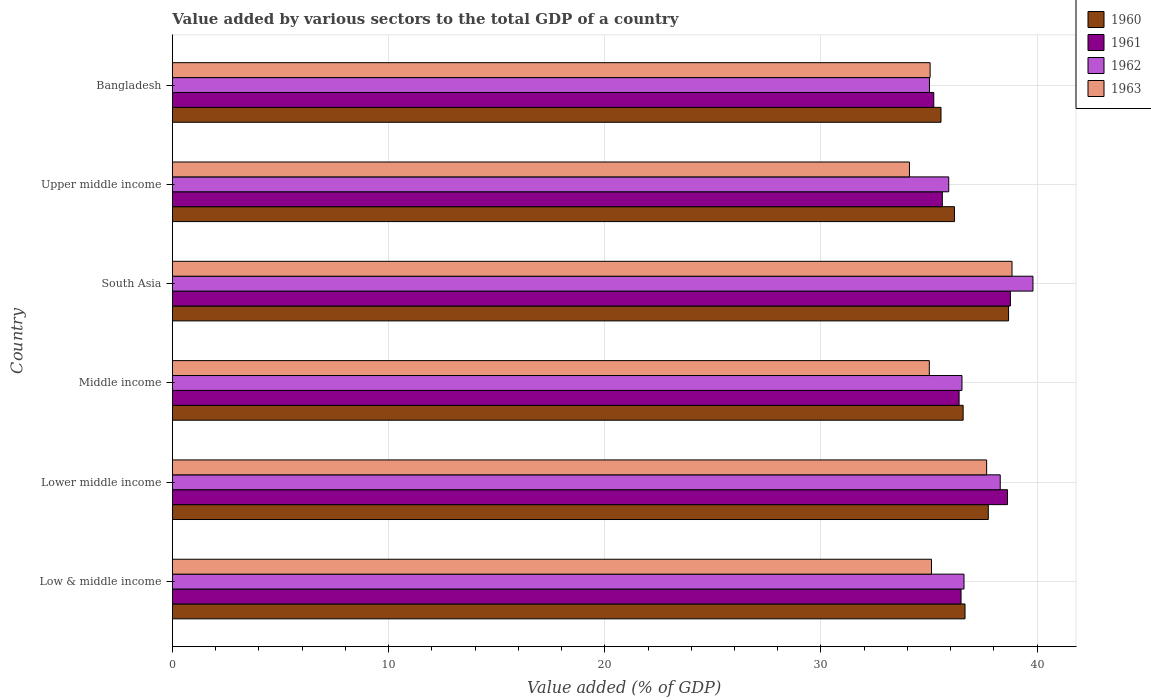How many bars are there on the 3rd tick from the top?
Offer a very short reply. 4. In how many cases, is the number of bars for a given country not equal to the number of legend labels?
Provide a short and direct response. 0. What is the value added by various sectors to the total GDP in 1962 in Upper middle income?
Ensure brevity in your answer.  35.91. Across all countries, what is the maximum value added by various sectors to the total GDP in 1960?
Keep it short and to the point. 38.68. Across all countries, what is the minimum value added by various sectors to the total GDP in 1962?
Your answer should be compact. 35.02. In which country was the value added by various sectors to the total GDP in 1960 maximum?
Offer a terse response. South Asia. What is the total value added by various sectors to the total GDP in 1962 in the graph?
Give a very brief answer. 222.16. What is the difference between the value added by various sectors to the total GDP in 1960 in Lower middle income and that in Middle income?
Provide a short and direct response. 1.16. What is the difference between the value added by various sectors to the total GDP in 1963 in Middle income and the value added by various sectors to the total GDP in 1961 in Low & middle income?
Offer a terse response. -1.47. What is the average value added by various sectors to the total GDP in 1960 per country?
Your answer should be very brief. 36.9. What is the difference between the value added by various sectors to the total GDP in 1963 and value added by various sectors to the total GDP in 1962 in South Asia?
Offer a very short reply. -0.97. What is the ratio of the value added by various sectors to the total GDP in 1962 in Middle income to that in South Asia?
Provide a succinct answer. 0.92. What is the difference between the highest and the second highest value added by various sectors to the total GDP in 1962?
Make the answer very short. 1.51. What is the difference between the highest and the lowest value added by various sectors to the total GDP in 1962?
Make the answer very short. 4.79. In how many countries, is the value added by various sectors to the total GDP in 1963 greater than the average value added by various sectors to the total GDP in 1963 taken over all countries?
Offer a very short reply. 2. Is the sum of the value added by various sectors to the total GDP in 1960 in South Asia and Upper middle income greater than the maximum value added by various sectors to the total GDP in 1961 across all countries?
Your answer should be compact. Yes. Is it the case that in every country, the sum of the value added by various sectors to the total GDP in 1960 and value added by various sectors to the total GDP in 1961 is greater than the sum of value added by various sectors to the total GDP in 1963 and value added by various sectors to the total GDP in 1962?
Your response must be concise. No. What does the 4th bar from the top in Middle income represents?
Provide a short and direct response. 1960. Is it the case that in every country, the sum of the value added by various sectors to the total GDP in 1963 and value added by various sectors to the total GDP in 1962 is greater than the value added by various sectors to the total GDP in 1961?
Give a very brief answer. Yes. Are all the bars in the graph horizontal?
Offer a terse response. Yes. Are the values on the major ticks of X-axis written in scientific E-notation?
Your answer should be very brief. No. Does the graph contain any zero values?
Offer a terse response. No. What is the title of the graph?
Your answer should be very brief. Value added by various sectors to the total GDP of a country. What is the label or title of the X-axis?
Your answer should be compact. Value added (% of GDP). What is the Value added (% of GDP) in 1960 in Low & middle income?
Provide a short and direct response. 36.66. What is the Value added (% of GDP) of 1961 in Low & middle income?
Make the answer very short. 36.48. What is the Value added (% of GDP) in 1962 in Low & middle income?
Give a very brief answer. 36.62. What is the Value added (% of GDP) of 1963 in Low & middle income?
Ensure brevity in your answer.  35.11. What is the Value added (% of GDP) of 1960 in Lower middle income?
Provide a succinct answer. 37.74. What is the Value added (% of GDP) in 1961 in Lower middle income?
Provide a succinct answer. 38.63. What is the Value added (% of GDP) in 1962 in Lower middle income?
Keep it short and to the point. 38.29. What is the Value added (% of GDP) in 1963 in Lower middle income?
Keep it short and to the point. 37.66. What is the Value added (% of GDP) of 1960 in Middle income?
Keep it short and to the point. 36.58. What is the Value added (% of GDP) in 1961 in Middle income?
Ensure brevity in your answer.  36.39. What is the Value added (% of GDP) in 1962 in Middle income?
Make the answer very short. 36.52. What is the Value added (% of GDP) of 1963 in Middle income?
Provide a succinct answer. 35.01. What is the Value added (% of GDP) of 1960 in South Asia?
Keep it short and to the point. 38.68. What is the Value added (% of GDP) of 1961 in South Asia?
Keep it short and to the point. 38.76. What is the Value added (% of GDP) in 1962 in South Asia?
Give a very brief answer. 39.81. What is the Value added (% of GDP) of 1963 in South Asia?
Your answer should be very brief. 38.84. What is the Value added (% of GDP) of 1960 in Upper middle income?
Make the answer very short. 36.17. What is the Value added (% of GDP) of 1961 in Upper middle income?
Offer a terse response. 35.61. What is the Value added (% of GDP) of 1962 in Upper middle income?
Give a very brief answer. 35.91. What is the Value added (% of GDP) of 1963 in Upper middle income?
Give a very brief answer. 34.09. What is the Value added (% of GDP) in 1960 in Bangladesh?
Offer a very short reply. 35.55. What is the Value added (% of GDP) of 1961 in Bangladesh?
Keep it short and to the point. 35.22. What is the Value added (% of GDP) of 1962 in Bangladesh?
Offer a very short reply. 35.02. What is the Value added (% of GDP) of 1963 in Bangladesh?
Provide a succinct answer. 35.05. Across all countries, what is the maximum Value added (% of GDP) of 1960?
Give a very brief answer. 38.68. Across all countries, what is the maximum Value added (% of GDP) of 1961?
Your answer should be compact. 38.76. Across all countries, what is the maximum Value added (% of GDP) of 1962?
Your answer should be very brief. 39.81. Across all countries, what is the maximum Value added (% of GDP) of 1963?
Your answer should be compact. 38.84. Across all countries, what is the minimum Value added (% of GDP) in 1960?
Your response must be concise. 35.55. Across all countries, what is the minimum Value added (% of GDP) of 1961?
Offer a terse response. 35.22. Across all countries, what is the minimum Value added (% of GDP) in 1962?
Your answer should be very brief. 35.02. Across all countries, what is the minimum Value added (% of GDP) of 1963?
Provide a succinct answer. 34.09. What is the total Value added (% of GDP) of 1960 in the graph?
Your answer should be compact. 221.38. What is the total Value added (% of GDP) of 1961 in the graph?
Your answer should be compact. 221.09. What is the total Value added (% of GDP) in 1962 in the graph?
Give a very brief answer. 222.16. What is the total Value added (% of GDP) in 1963 in the graph?
Ensure brevity in your answer.  215.76. What is the difference between the Value added (% of GDP) of 1960 in Low & middle income and that in Lower middle income?
Make the answer very short. -1.08. What is the difference between the Value added (% of GDP) of 1961 in Low & middle income and that in Lower middle income?
Give a very brief answer. -2.15. What is the difference between the Value added (% of GDP) of 1962 in Low & middle income and that in Lower middle income?
Your response must be concise. -1.68. What is the difference between the Value added (% of GDP) in 1963 in Low & middle income and that in Lower middle income?
Offer a very short reply. -2.55. What is the difference between the Value added (% of GDP) of 1960 in Low & middle income and that in Middle income?
Offer a very short reply. 0.09. What is the difference between the Value added (% of GDP) in 1961 in Low & middle income and that in Middle income?
Your answer should be very brief. 0.09. What is the difference between the Value added (% of GDP) of 1962 in Low & middle income and that in Middle income?
Offer a terse response. 0.09. What is the difference between the Value added (% of GDP) in 1963 in Low & middle income and that in Middle income?
Ensure brevity in your answer.  0.1. What is the difference between the Value added (% of GDP) in 1960 in Low & middle income and that in South Asia?
Provide a succinct answer. -2.01. What is the difference between the Value added (% of GDP) in 1961 in Low & middle income and that in South Asia?
Offer a terse response. -2.28. What is the difference between the Value added (% of GDP) of 1962 in Low & middle income and that in South Asia?
Keep it short and to the point. -3.19. What is the difference between the Value added (% of GDP) in 1963 in Low & middle income and that in South Asia?
Your answer should be very brief. -3.72. What is the difference between the Value added (% of GDP) in 1960 in Low & middle income and that in Upper middle income?
Your answer should be very brief. 0.49. What is the difference between the Value added (% of GDP) of 1961 in Low & middle income and that in Upper middle income?
Give a very brief answer. 0.87. What is the difference between the Value added (% of GDP) of 1962 in Low & middle income and that in Upper middle income?
Give a very brief answer. 0.71. What is the difference between the Value added (% of GDP) of 1963 in Low & middle income and that in Upper middle income?
Give a very brief answer. 1.02. What is the difference between the Value added (% of GDP) in 1960 in Low & middle income and that in Bangladesh?
Provide a short and direct response. 1.11. What is the difference between the Value added (% of GDP) of 1961 in Low & middle income and that in Bangladesh?
Offer a very short reply. 1.26. What is the difference between the Value added (% of GDP) in 1962 in Low & middle income and that in Bangladesh?
Your response must be concise. 1.6. What is the difference between the Value added (% of GDP) of 1963 in Low & middle income and that in Bangladesh?
Offer a very short reply. 0.06. What is the difference between the Value added (% of GDP) of 1960 in Lower middle income and that in Middle income?
Provide a succinct answer. 1.16. What is the difference between the Value added (% of GDP) of 1961 in Lower middle income and that in Middle income?
Offer a very short reply. 2.24. What is the difference between the Value added (% of GDP) in 1962 in Lower middle income and that in Middle income?
Your answer should be compact. 1.77. What is the difference between the Value added (% of GDP) of 1963 in Lower middle income and that in Middle income?
Keep it short and to the point. 2.65. What is the difference between the Value added (% of GDP) of 1960 in Lower middle income and that in South Asia?
Provide a short and direct response. -0.94. What is the difference between the Value added (% of GDP) of 1961 in Lower middle income and that in South Asia?
Provide a succinct answer. -0.13. What is the difference between the Value added (% of GDP) in 1962 in Lower middle income and that in South Asia?
Your answer should be very brief. -1.51. What is the difference between the Value added (% of GDP) in 1963 in Lower middle income and that in South Asia?
Make the answer very short. -1.17. What is the difference between the Value added (% of GDP) of 1960 in Lower middle income and that in Upper middle income?
Your answer should be compact. 1.57. What is the difference between the Value added (% of GDP) of 1961 in Lower middle income and that in Upper middle income?
Your answer should be very brief. 3.02. What is the difference between the Value added (% of GDP) in 1962 in Lower middle income and that in Upper middle income?
Keep it short and to the point. 2.38. What is the difference between the Value added (% of GDP) of 1963 in Lower middle income and that in Upper middle income?
Your response must be concise. 3.57. What is the difference between the Value added (% of GDP) in 1960 in Lower middle income and that in Bangladesh?
Your response must be concise. 2.19. What is the difference between the Value added (% of GDP) of 1961 in Lower middle income and that in Bangladesh?
Provide a succinct answer. 3.41. What is the difference between the Value added (% of GDP) of 1962 in Lower middle income and that in Bangladesh?
Ensure brevity in your answer.  3.27. What is the difference between the Value added (% of GDP) in 1963 in Lower middle income and that in Bangladesh?
Your answer should be compact. 2.61. What is the difference between the Value added (% of GDP) of 1960 in Middle income and that in South Asia?
Your answer should be compact. -2.1. What is the difference between the Value added (% of GDP) in 1961 in Middle income and that in South Asia?
Your answer should be very brief. -2.37. What is the difference between the Value added (% of GDP) in 1962 in Middle income and that in South Asia?
Your answer should be compact. -3.28. What is the difference between the Value added (% of GDP) of 1963 in Middle income and that in South Asia?
Provide a short and direct response. -3.83. What is the difference between the Value added (% of GDP) of 1960 in Middle income and that in Upper middle income?
Your answer should be very brief. 0.4. What is the difference between the Value added (% of GDP) in 1961 in Middle income and that in Upper middle income?
Provide a succinct answer. 0.78. What is the difference between the Value added (% of GDP) of 1962 in Middle income and that in Upper middle income?
Give a very brief answer. 0.61. What is the difference between the Value added (% of GDP) in 1963 in Middle income and that in Upper middle income?
Your answer should be compact. 0.92. What is the difference between the Value added (% of GDP) of 1960 in Middle income and that in Bangladesh?
Your response must be concise. 1.02. What is the difference between the Value added (% of GDP) in 1961 in Middle income and that in Bangladesh?
Your response must be concise. 1.17. What is the difference between the Value added (% of GDP) of 1962 in Middle income and that in Bangladesh?
Your answer should be compact. 1.5. What is the difference between the Value added (% of GDP) of 1963 in Middle income and that in Bangladesh?
Provide a short and direct response. -0.04. What is the difference between the Value added (% of GDP) of 1960 in South Asia and that in Upper middle income?
Make the answer very short. 2.5. What is the difference between the Value added (% of GDP) of 1961 in South Asia and that in Upper middle income?
Offer a terse response. 3.15. What is the difference between the Value added (% of GDP) of 1962 in South Asia and that in Upper middle income?
Offer a terse response. 3.9. What is the difference between the Value added (% of GDP) of 1963 in South Asia and that in Upper middle income?
Make the answer very short. 4.74. What is the difference between the Value added (% of GDP) in 1960 in South Asia and that in Bangladesh?
Your answer should be very brief. 3.12. What is the difference between the Value added (% of GDP) of 1961 in South Asia and that in Bangladesh?
Your answer should be very brief. 3.54. What is the difference between the Value added (% of GDP) in 1962 in South Asia and that in Bangladesh?
Ensure brevity in your answer.  4.79. What is the difference between the Value added (% of GDP) of 1963 in South Asia and that in Bangladesh?
Provide a short and direct response. 3.79. What is the difference between the Value added (% of GDP) in 1960 in Upper middle income and that in Bangladesh?
Your response must be concise. 0.62. What is the difference between the Value added (% of GDP) of 1961 in Upper middle income and that in Bangladesh?
Your answer should be compact. 0.4. What is the difference between the Value added (% of GDP) in 1962 in Upper middle income and that in Bangladesh?
Give a very brief answer. 0.89. What is the difference between the Value added (% of GDP) of 1963 in Upper middle income and that in Bangladesh?
Give a very brief answer. -0.96. What is the difference between the Value added (% of GDP) in 1960 in Low & middle income and the Value added (% of GDP) in 1961 in Lower middle income?
Offer a terse response. -1.97. What is the difference between the Value added (% of GDP) in 1960 in Low & middle income and the Value added (% of GDP) in 1962 in Lower middle income?
Ensure brevity in your answer.  -1.63. What is the difference between the Value added (% of GDP) in 1960 in Low & middle income and the Value added (% of GDP) in 1963 in Lower middle income?
Provide a short and direct response. -1. What is the difference between the Value added (% of GDP) of 1961 in Low & middle income and the Value added (% of GDP) of 1962 in Lower middle income?
Provide a short and direct response. -1.81. What is the difference between the Value added (% of GDP) in 1961 in Low & middle income and the Value added (% of GDP) in 1963 in Lower middle income?
Provide a short and direct response. -1.18. What is the difference between the Value added (% of GDP) of 1962 in Low & middle income and the Value added (% of GDP) of 1963 in Lower middle income?
Give a very brief answer. -1.05. What is the difference between the Value added (% of GDP) in 1960 in Low & middle income and the Value added (% of GDP) in 1961 in Middle income?
Your answer should be compact. 0.27. What is the difference between the Value added (% of GDP) in 1960 in Low & middle income and the Value added (% of GDP) in 1962 in Middle income?
Offer a terse response. 0.14. What is the difference between the Value added (% of GDP) of 1960 in Low & middle income and the Value added (% of GDP) of 1963 in Middle income?
Your answer should be very brief. 1.65. What is the difference between the Value added (% of GDP) in 1961 in Low & middle income and the Value added (% of GDP) in 1962 in Middle income?
Your answer should be compact. -0.04. What is the difference between the Value added (% of GDP) of 1961 in Low & middle income and the Value added (% of GDP) of 1963 in Middle income?
Keep it short and to the point. 1.47. What is the difference between the Value added (% of GDP) in 1962 in Low & middle income and the Value added (% of GDP) in 1963 in Middle income?
Your response must be concise. 1.6. What is the difference between the Value added (% of GDP) of 1960 in Low & middle income and the Value added (% of GDP) of 1961 in South Asia?
Give a very brief answer. -2.1. What is the difference between the Value added (% of GDP) of 1960 in Low & middle income and the Value added (% of GDP) of 1962 in South Asia?
Give a very brief answer. -3.14. What is the difference between the Value added (% of GDP) in 1960 in Low & middle income and the Value added (% of GDP) in 1963 in South Asia?
Offer a terse response. -2.17. What is the difference between the Value added (% of GDP) of 1961 in Low & middle income and the Value added (% of GDP) of 1962 in South Asia?
Make the answer very short. -3.33. What is the difference between the Value added (% of GDP) of 1961 in Low & middle income and the Value added (% of GDP) of 1963 in South Asia?
Provide a succinct answer. -2.36. What is the difference between the Value added (% of GDP) of 1962 in Low & middle income and the Value added (% of GDP) of 1963 in South Asia?
Keep it short and to the point. -2.22. What is the difference between the Value added (% of GDP) in 1960 in Low & middle income and the Value added (% of GDP) in 1961 in Upper middle income?
Your response must be concise. 1.05. What is the difference between the Value added (% of GDP) in 1960 in Low & middle income and the Value added (% of GDP) in 1962 in Upper middle income?
Make the answer very short. 0.75. What is the difference between the Value added (% of GDP) in 1960 in Low & middle income and the Value added (% of GDP) in 1963 in Upper middle income?
Your response must be concise. 2.57. What is the difference between the Value added (% of GDP) in 1961 in Low & middle income and the Value added (% of GDP) in 1962 in Upper middle income?
Give a very brief answer. 0.57. What is the difference between the Value added (% of GDP) of 1961 in Low & middle income and the Value added (% of GDP) of 1963 in Upper middle income?
Provide a short and direct response. 2.39. What is the difference between the Value added (% of GDP) of 1962 in Low & middle income and the Value added (% of GDP) of 1963 in Upper middle income?
Your answer should be compact. 2.52. What is the difference between the Value added (% of GDP) in 1960 in Low & middle income and the Value added (% of GDP) in 1961 in Bangladesh?
Offer a terse response. 1.44. What is the difference between the Value added (% of GDP) of 1960 in Low & middle income and the Value added (% of GDP) of 1962 in Bangladesh?
Offer a terse response. 1.65. What is the difference between the Value added (% of GDP) in 1960 in Low & middle income and the Value added (% of GDP) in 1963 in Bangladesh?
Provide a short and direct response. 1.61. What is the difference between the Value added (% of GDP) of 1961 in Low & middle income and the Value added (% of GDP) of 1962 in Bangladesh?
Provide a succinct answer. 1.46. What is the difference between the Value added (% of GDP) of 1961 in Low & middle income and the Value added (% of GDP) of 1963 in Bangladesh?
Keep it short and to the point. 1.43. What is the difference between the Value added (% of GDP) of 1962 in Low & middle income and the Value added (% of GDP) of 1963 in Bangladesh?
Your response must be concise. 1.57. What is the difference between the Value added (% of GDP) in 1960 in Lower middle income and the Value added (% of GDP) in 1961 in Middle income?
Your answer should be compact. 1.35. What is the difference between the Value added (% of GDP) in 1960 in Lower middle income and the Value added (% of GDP) in 1962 in Middle income?
Offer a terse response. 1.22. What is the difference between the Value added (% of GDP) in 1960 in Lower middle income and the Value added (% of GDP) in 1963 in Middle income?
Keep it short and to the point. 2.73. What is the difference between the Value added (% of GDP) in 1961 in Lower middle income and the Value added (% of GDP) in 1962 in Middle income?
Make the answer very short. 2.11. What is the difference between the Value added (% of GDP) in 1961 in Lower middle income and the Value added (% of GDP) in 1963 in Middle income?
Your answer should be compact. 3.62. What is the difference between the Value added (% of GDP) of 1962 in Lower middle income and the Value added (% of GDP) of 1963 in Middle income?
Give a very brief answer. 3.28. What is the difference between the Value added (% of GDP) in 1960 in Lower middle income and the Value added (% of GDP) in 1961 in South Asia?
Offer a very short reply. -1.02. What is the difference between the Value added (% of GDP) in 1960 in Lower middle income and the Value added (% of GDP) in 1962 in South Asia?
Ensure brevity in your answer.  -2.07. What is the difference between the Value added (% of GDP) of 1960 in Lower middle income and the Value added (% of GDP) of 1963 in South Asia?
Make the answer very short. -1.1. What is the difference between the Value added (% of GDP) in 1961 in Lower middle income and the Value added (% of GDP) in 1962 in South Asia?
Make the answer very short. -1.18. What is the difference between the Value added (% of GDP) of 1961 in Lower middle income and the Value added (% of GDP) of 1963 in South Asia?
Your answer should be very brief. -0.21. What is the difference between the Value added (% of GDP) in 1962 in Lower middle income and the Value added (% of GDP) in 1963 in South Asia?
Provide a succinct answer. -0.55. What is the difference between the Value added (% of GDP) in 1960 in Lower middle income and the Value added (% of GDP) in 1961 in Upper middle income?
Ensure brevity in your answer.  2.13. What is the difference between the Value added (% of GDP) of 1960 in Lower middle income and the Value added (% of GDP) of 1962 in Upper middle income?
Your answer should be compact. 1.83. What is the difference between the Value added (% of GDP) of 1960 in Lower middle income and the Value added (% of GDP) of 1963 in Upper middle income?
Ensure brevity in your answer.  3.65. What is the difference between the Value added (% of GDP) of 1961 in Lower middle income and the Value added (% of GDP) of 1962 in Upper middle income?
Make the answer very short. 2.72. What is the difference between the Value added (% of GDP) in 1961 in Lower middle income and the Value added (% of GDP) in 1963 in Upper middle income?
Give a very brief answer. 4.54. What is the difference between the Value added (% of GDP) in 1962 in Lower middle income and the Value added (% of GDP) in 1963 in Upper middle income?
Provide a short and direct response. 4.2. What is the difference between the Value added (% of GDP) in 1960 in Lower middle income and the Value added (% of GDP) in 1961 in Bangladesh?
Keep it short and to the point. 2.52. What is the difference between the Value added (% of GDP) in 1960 in Lower middle income and the Value added (% of GDP) in 1962 in Bangladesh?
Your response must be concise. 2.72. What is the difference between the Value added (% of GDP) in 1960 in Lower middle income and the Value added (% of GDP) in 1963 in Bangladesh?
Your answer should be compact. 2.69. What is the difference between the Value added (% of GDP) of 1961 in Lower middle income and the Value added (% of GDP) of 1962 in Bangladesh?
Make the answer very short. 3.61. What is the difference between the Value added (% of GDP) in 1961 in Lower middle income and the Value added (% of GDP) in 1963 in Bangladesh?
Give a very brief answer. 3.58. What is the difference between the Value added (% of GDP) in 1962 in Lower middle income and the Value added (% of GDP) in 1963 in Bangladesh?
Ensure brevity in your answer.  3.24. What is the difference between the Value added (% of GDP) of 1960 in Middle income and the Value added (% of GDP) of 1961 in South Asia?
Your answer should be compact. -2.19. What is the difference between the Value added (% of GDP) in 1960 in Middle income and the Value added (% of GDP) in 1962 in South Asia?
Your answer should be very brief. -3.23. What is the difference between the Value added (% of GDP) in 1960 in Middle income and the Value added (% of GDP) in 1963 in South Asia?
Offer a very short reply. -2.26. What is the difference between the Value added (% of GDP) in 1961 in Middle income and the Value added (% of GDP) in 1962 in South Asia?
Give a very brief answer. -3.42. What is the difference between the Value added (% of GDP) of 1961 in Middle income and the Value added (% of GDP) of 1963 in South Asia?
Ensure brevity in your answer.  -2.45. What is the difference between the Value added (% of GDP) in 1962 in Middle income and the Value added (% of GDP) in 1963 in South Asia?
Provide a succinct answer. -2.31. What is the difference between the Value added (% of GDP) in 1960 in Middle income and the Value added (% of GDP) in 1961 in Upper middle income?
Provide a succinct answer. 0.96. What is the difference between the Value added (% of GDP) in 1960 in Middle income and the Value added (% of GDP) in 1962 in Upper middle income?
Ensure brevity in your answer.  0.67. What is the difference between the Value added (% of GDP) of 1960 in Middle income and the Value added (% of GDP) of 1963 in Upper middle income?
Your answer should be compact. 2.48. What is the difference between the Value added (% of GDP) in 1961 in Middle income and the Value added (% of GDP) in 1962 in Upper middle income?
Ensure brevity in your answer.  0.48. What is the difference between the Value added (% of GDP) of 1961 in Middle income and the Value added (% of GDP) of 1963 in Upper middle income?
Your response must be concise. 2.3. What is the difference between the Value added (% of GDP) of 1962 in Middle income and the Value added (% of GDP) of 1963 in Upper middle income?
Keep it short and to the point. 2.43. What is the difference between the Value added (% of GDP) of 1960 in Middle income and the Value added (% of GDP) of 1961 in Bangladesh?
Give a very brief answer. 1.36. What is the difference between the Value added (% of GDP) of 1960 in Middle income and the Value added (% of GDP) of 1962 in Bangladesh?
Offer a terse response. 1.56. What is the difference between the Value added (% of GDP) in 1960 in Middle income and the Value added (% of GDP) in 1963 in Bangladesh?
Offer a very short reply. 1.53. What is the difference between the Value added (% of GDP) in 1961 in Middle income and the Value added (% of GDP) in 1962 in Bangladesh?
Keep it short and to the point. 1.37. What is the difference between the Value added (% of GDP) of 1961 in Middle income and the Value added (% of GDP) of 1963 in Bangladesh?
Provide a short and direct response. 1.34. What is the difference between the Value added (% of GDP) in 1962 in Middle income and the Value added (% of GDP) in 1963 in Bangladesh?
Ensure brevity in your answer.  1.47. What is the difference between the Value added (% of GDP) in 1960 in South Asia and the Value added (% of GDP) in 1961 in Upper middle income?
Your answer should be compact. 3.06. What is the difference between the Value added (% of GDP) in 1960 in South Asia and the Value added (% of GDP) in 1962 in Upper middle income?
Offer a terse response. 2.77. What is the difference between the Value added (% of GDP) in 1960 in South Asia and the Value added (% of GDP) in 1963 in Upper middle income?
Offer a terse response. 4.58. What is the difference between the Value added (% of GDP) in 1961 in South Asia and the Value added (% of GDP) in 1962 in Upper middle income?
Your answer should be compact. 2.85. What is the difference between the Value added (% of GDP) of 1961 in South Asia and the Value added (% of GDP) of 1963 in Upper middle income?
Offer a very short reply. 4.67. What is the difference between the Value added (% of GDP) of 1962 in South Asia and the Value added (% of GDP) of 1963 in Upper middle income?
Keep it short and to the point. 5.71. What is the difference between the Value added (% of GDP) of 1960 in South Asia and the Value added (% of GDP) of 1961 in Bangladesh?
Ensure brevity in your answer.  3.46. What is the difference between the Value added (% of GDP) in 1960 in South Asia and the Value added (% of GDP) in 1962 in Bangladesh?
Your answer should be compact. 3.66. What is the difference between the Value added (% of GDP) in 1960 in South Asia and the Value added (% of GDP) in 1963 in Bangladesh?
Make the answer very short. 3.63. What is the difference between the Value added (% of GDP) of 1961 in South Asia and the Value added (% of GDP) of 1962 in Bangladesh?
Your answer should be very brief. 3.74. What is the difference between the Value added (% of GDP) of 1961 in South Asia and the Value added (% of GDP) of 1963 in Bangladesh?
Provide a short and direct response. 3.71. What is the difference between the Value added (% of GDP) in 1962 in South Asia and the Value added (% of GDP) in 1963 in Bangladesh?
Provide a short and direct response. 4.76. What is the difference between the Value added (% of GDP) in 1960 in Upper middle income and the Value added (% of GDP) in 1961 in Bangladesh?
Your answer should be compact. 0.96. What is the difference between the Value added (% of GDP) of 1960 in Upper middle income and the Value added (% of GDP) of 1962 in Bangladesh?
Offer a terse response. 1.16. What is the difference between the Value added (% of GDP) in 1960 in Upper middle income and the Value added (% of GDP) in 1963 in Bangladesh?
Ensure brevity in your answer.  1.12. What is the difference between the Value added (% of GDP) in 1961 in Upper middle income and the Value added (% of GDP) in 1962 in Bangladesh?
Give a very brief answer. 0.6. What is the difference between the Value added (% of GDP) of 1961 in Upper middle income and the Value added (% of GDP) of 1963 in Bangladesh?
Provide a succinct answer. 0.56. What is the difference between the Value added (% of GDP) of 1962 in Upper middle income and the Value added (% of GDP) of 1963 in Bangladesh?
Offer a terse response. 0.86. What is the average Value added (% of GDP) in 1960 per country?
Make the answer very short. 36.9. What is the average Value added (% of GDP) of 1961 per country?
Offer a terse response. 36.85. What is the average Value added (% of GDP) in 1962 per country?
Your answer should be very brief. 37.03. What is the average Value added (% of GDP) of 1963 per country?
Provide a short and direct response. 35.96. What is the difference between the Value added (% of GDP) of 1960 and Value added (% of GDP) of 1961 in Low & middle income?
Ensure brevity in your answer.  0.18. What is the difference between the Value added (% of GDP) in 1960 and Value added (% of GDP) in 1962 in Low & middle income?
Offer a terse response. 0.05. What is the difference between the Value added (% of GDP) of 1960 and Value added (% of GDP) of 1963 in Low & middle income?
Give a very brief answer. 1.55. What is the difference between the Value added (% of GDP) of 1961 and Value added (% of GDP) of 1962 in Low & middle income?
Your answer should be very brief. -0.14. What is the difference between the Value added (% of GDP) in 1961 and Value added (% of GDP) in 1963 in Low & middle income?
Offer a terse response. 1.37. What is the difference between the Value added (% of GDP) in 1962 and Value added (% of GDP) in 1963 in Low & middle income?
Provide a short and direct response. 1.5. What is the difference between the Value added (% of GDP) of 1960 and Value added (% of GDP) of 1961 in Lower middle income?
Your answer should be very brief. -0.89. What is the difference between the Value added (% of GDP) in 1960 and Value added (% of GDP) in 1962 in Lower middle income?
Offer a terse response. -0.55. What is the difference between the Value added (% of GDP) in 1960 and Value added (% of GDP) in 1963 in Lower middle income?
Offer a terse response. 0.08. What is the difference between the Value added (% of GDP) in 1961 and Value added (% of GDP) in 1962 in Lower middle income?
Offer a terse response. 0.34. What is the difference between the Value added (% of GDP) in 1961 and Value added (% of GDP) in 1963 in Lower middle income?
Provide a short and direct response. 0.97. What is the difference between the Value added (% of GDP) in 1962 and Value added (% of GDP) in 1963 in Lower middle income?
Make the answer very short. 0.63. What is the difference between the Value added (% of GDP) in 1960 and Value added (% of GDP) in 1961 in Middle income?
Your response must be concise. 0.19. What is the difference between the Value added (% of GDP) of 1960 and Value added (% of GDP) of 1962 in Middle income?
Give a very brief answer. 0.05. What is the difference between the Value added (% of GDP) in 1960 and Value added (% of GDP) in 1963 in Middle income?
Keep it short and to the point. 1.56. What is the difference between the Value added (% of GDP) of 1961 and Value added (% of GDP) of 1962 in Middle income?
Give a very brief answer. -0.13. What is the difference between the Value added (% of GDP) of 1961 and Value added (% of GDP) of 1963 in Middle income?
Make the answer very short. 1.38. What is the difference between the Value added (% of GDP) in 1962 and Value added (% of GDP) in 1963 in Middle income?
Give a very brief answer. 1.51. What is the difference between the Value added (% of GDP) in 1960 and Value added (% of GDP) in 1961 in South Asia?
Offer a very short reply. -0.09. What is the difference between the Value added (% of GDP) of 1960 and Value added (% of GDP) of 1962 in South Asia?
Your answer should be very brief. -1.13. What is the difference between the Value added (% of GDP) in 1960 and Value added (% of GDP) in 1963 in South Asia?
Provide a succinct answer. -0.16. What is the difference between the Value added (% of GDP) of 1961 and Value added (% of GDP) of 1962 in South Asia?
Your answer should be compact. -1.04. What is the difference between the Value added (% of GDP) in 1961 and Value added (% of GDP) in 1963 in South Asia?
Your answer should be very brief. -0.07. What is the difference between the Value added (% of GDP) of 1962 and Value added (% of GDP) of 1963 in South Asia?
Offer a terse response. 0.97. What is the difference between the Value added (% of GDP) of 1960 and Value added (% of GDP) of 1961 in Upper middle income?
Offer a terse response. 0.56. What is the difference between the Value added (% of GDP) in 1960 and Value added (% of GDP) in 1962 in Upper middle income?
Keep it short and to the point. 0.26. What is the difference between the Value added (% of GDP) of 1960 and Value added (% of GDP) of 1963 in Upper middle income?
Provide a short and direct response. 2.08. What is the difference between the Value added (% of GDP) of 1961 and Value added (% of GDP) of 1962 in Upper middle income?
Ensure brevity in your answer.  -0.3. What is the difference between the Value added (% of GDP) in 1961 and Value added (% of GDP) in 1963 in Upper middle income?
Offer a very short reply. 1.52. What is the difference between the Value added (% of GDP) of 1962 and Value added (% of GDP) of 1963 in Upper middle income?
Make the answer very short. 1.82. What is the difference between the Value added (% of GDP) of 1960 and Value added (% of GDP) of 1961 in Bangladesh?
Make the answer very short. 0.33. What is the difference between the Value added (% of GDP) of 1960 and Value added (% of GDP) of 1962 in Bangladesh?
Your answer should be very brief. 0.53. What is the difference between the Value added (% of GDP) of 1960 and Value added (% of GDP) of 1963 in Bangladesh?
Your answer should be very brief. 0.5. What is the difference between the Value added (% of GDP) of 1961 and Value added (% of GDP) of 1962 in Bangladesh?
Make the answer very short. 0.2. What is the difference between the Value added (% of GDP) of 1961 and Value added (% of GDP) of 1963 in Bangladesh?
Keep it short and to the point. 0.17. What is the difference between the Value added (% of GDP) in 1962 and Value added (% of GDP) in 1963 in Bangladesh?
Keep it short and to the point. -0.03. What is the ratio of the Value added (% of GDP) of 1960 in Low & middle income to that in Lower middle income?
Ensure brevity in your answer.  0.97. What is the ratio of the Value added (% of GDP) in 1961 in Low & middle income to that in Lower middle income?
Your answer should be very brief. 0.94. What is the ratio of the Value added (% of GDP) in 1962 in Low & middle income to that in Lower middle income?
Keep it short and to the point. 0.96. What is the ratio of the Value added (% of GDP) in 1963 in Low & middle income to that in Lower middle income?
Make the answer very short. 0.93. What is the ratio of the Value added (% of GDP) in 1961 in Low & middle income to that in Middle income?
Your response must be concise. 1. What is the ratio of the Value added (% of GDP) of 1960 in Low & middle income to that in South Asia?
Offer a very short reply. 0.95. What is the ratio of the Value added (% of GDP) of 1961 in Low & middle income to that in South Asia?
Offer a very short reply. 0.94. What is the ratio of the Value added (% of GDP) of 1962 in Low & middle income to that in South Asia?
Offer a very short reply. 0.92. What is the ratio of the Value added (% of GDP) of 1963 in Low & middle income to that in South Asia?
Provide a succinct answer. 0.9. What is the ratio of the Value added (% of GDP) in 1960 in Low & middle income to that in Upper middle income?
Your answer should be very brief. 1.01. What is the ratio of the Value added (% of GDP) of 1961 in Low & middle income to that in Upper middle income?
Give a very brief answer. 1.02. What is the ratio of the Value added (% of GDP) in 1962 in Low & middle income to that in Upper middle income?
Your answer should be very brief. 1.02. What is the ratio of the Value added (% of GDP) in 1963 in Low & middle income to that in Upper middle income?
Keep it short and to the point. 1.03. What is the ratio of the Value added (% of GDP) of 1960 in Low & middle income to that in Bangladesh?
Your answer should be very brief. 1.03. What is the ratio of the Value added (% of GDP) in 1961 in Low & middle income to that in Bangladesh?
Your response must be concise. 1.04. What is the ratio of the Value added (% of GDP) in 1962 in Low & middle income to that in Bangladesh?
Your answer should be compact. 1.05. What is the ratio of the Value added (% of GDP) of 1963 in Low & middle income to that in Bangladesh?
Provide a succinct answer. 1. What is the ratio of the Value added (% of GDP) of 1960 in Lower middle income to that in Middle income?
Provide a succinct answer. 1.03. What is the ratio of the Value added (% of GDP) of 1961 in Lower middle income to that in Middle income?
Your answer should be very brief. 1.06. What is the ratio of the Value added (% of GDP) of 1962 in Lower middle income to that in Middle income?
Provide a short and direct response. 1.05. What is the ratio of the Value added (% of GDP) of 1963 in Lower middle income to that in Middle income?
Give a very brief answer. 1.08. What is the ratio of the Value added (% of GDP) of 1960 in Lower middle income to that in South Asia?
Offer a terse response. 0.98. What is the ratio of the Value added (% of GDP) of 1963 in Lower middle income to that in South Asia?
Make the answer very short. 0.97. What is the ratio of the Value added (% of GDP) in 1960 in Lower middle income to that in Upper middle income?
Ensure brevity in your answer.  1.04. What is the ratio of the Value added (% of GDP) in 1961 in Lower middle income to that in Upper middle income?
Keep it short and to the point. 1.08. What is the ratio of the Value added (% of GDP) of 1962 in Lower middle income to that in Upper middle income?
Your answer should be compact. 1.07. What is the ratio of the Value added (% of GDP) in 1963 in Lower middle income to that in Upper middle income?
Provide a short and direct response. 1.1. What is the ratio of the Value added (% of GDP) of 1960 in Lower middle income to that in Bangladesh?
Provide a short and direct response. 1.06. What is the ratio of the Value added (% of GDP) in 1961 in Lower middle income to that in Bangladesh?
Give a very brief answer. 1.1. What is the ratio of the Value added (% of GDP) of 1962 in Lower middle income to that in Bangladesh?
Give a very brief answer. 1.09. What is the ratio of the Value added (% of GDP) of 1963 in Lower middle income to that in Bangladesh?
Your response must be concise. 1.07. What is the ratio of the Value added (% of GDP) in 1960 in Middle income to that in South Asia?
Keep it short and to the point. 0.95. What is the ratio of the Value added (% of GDP) of 1961 in Middle income to that in South Asia?
Make the answer very short. 0.94. What is the ratio of the Value added (% of GDP) of 1962 in Middle income to that in South Asia?
Offer a terse response. 0.92. What is the ratio of the Value added (% of GDP) in 1963 in Middle income to that in South Asia?
Offer a terse response. 0.9. What is the ratio of the Value added (% of GDP) of 1960 in Middle income to that in Upper middle income?
Offer a terse response. 1.01. What is the ratio of the Value added (% of GDP) of 1961 in Middle income to that in Upper middle income?
Make the answer very short. 1.02. What is the ratio of the Value added (% of GDP) in 1962 in Middle income to that in Upper middle income?
Your answer should be very brief. 1.02. What is the ratio of the Value added (% of GDP) of 1963 in Middle income to that in Upper middle income?
Make the answer very short. 1.03. What is the ratio of the Value added (% of GDP) in 1960 in Middle income to that in Bangladesh?
Your response must be concise. 1.03. What is the ratio of the Value added (% of GDP) of 1962 in Middle income to that in Bangladesh?
Ensure brevity in your answer.  1.04. What is the ratio of the Value added (% of GDP) in 1963 in Middle income to that in Bangladesh?
Your response must be concise. 1. What is the ratio of the Value added (% of GDP) of 1960 in South Asia to that in Upper middle income?
Ensure brevity in your answer.  1.07. What is the ratio of the Value added (% of GDP) in 1961 in South Asia to that in Upper middle income?
Keep it short and to the point. 1.09. What is the ratio of the Value added (% of GDP) of 1962 in South Asia to that in Upper middle income?
Offer a terse response. 1.11. What is the ratio of the Value added (% of GDP) in 1963 in South Asia to that in Upper middle income?
Provide a short and direct response. 1.14. What is the ratio of the Value added (% of GDP) in 1960 in South Asia to that in Bangladesh?
Make the answer very short. 1.09. What is the ratio of the Value added (% of GDP) of 1961 in South Asia to that in Bangladesh?
Your answer should be very brief. 1.1. What is the ratio of the Value added (% of GDP) of 1962 in South Asia to that in Bangladesh?
Your response must be concise. 1.14. What is the ratio of the Value added (% of GDP) of 1963 in South Asia to that in Bangladesh?
Give a very brief answer. 1.11. What is the ratio of the Value added (% of GDP) in 1960 in Upper middle income to that in Bangladesh?
Keep it short and to the point. 1.02. What is the ratio of the Value added (% of GDP) of 1961 in Upper middle income to that in Bangladesh?
Ensure brevity in your answer.  1.01. What is the ratio of the Value added (% of GDP) in 1962 in Upper middle income to that in Bangladesh?
Your answer should be compact. 1.03. What is the ratio of the Value added (% of GDP) in 1963 in Upper middle income to that in Bangladesh?
Your answer should be very brief. 0.97. What is the difference between the highest and the second highest Value added (% of GDP) in 1960?
Keep it short and to the point. 0.94. What is the difference between the highest and the second highest Value added (% of GDP) of 1961?
Offer a very short reply. 0.13. What is the difference between the highest and the second highest Value added (% of GDP) of 1962?
Give a very brief answer. 1.51. What is the difference between the highest and the second highest Value added (% of GDP) of 1963?
Your answer should be compact. 1.17. What is the difference between the highest and the lowest Value added (% of GDP) in 1960?
Provide a short and direct response. 3.12. What is the difference between the highest and the lowest Value added (% of GDP) of 1961?
Offer a very short reply. 3.54. What is the difference between the highest and the lowest Value added (% of GDP) of 1962?
Keep it short and to the point. 4.79. What is the difference between the highest and the lowest Value added (% of GDP) of 1963?
Make the answer very short. 4.74. 